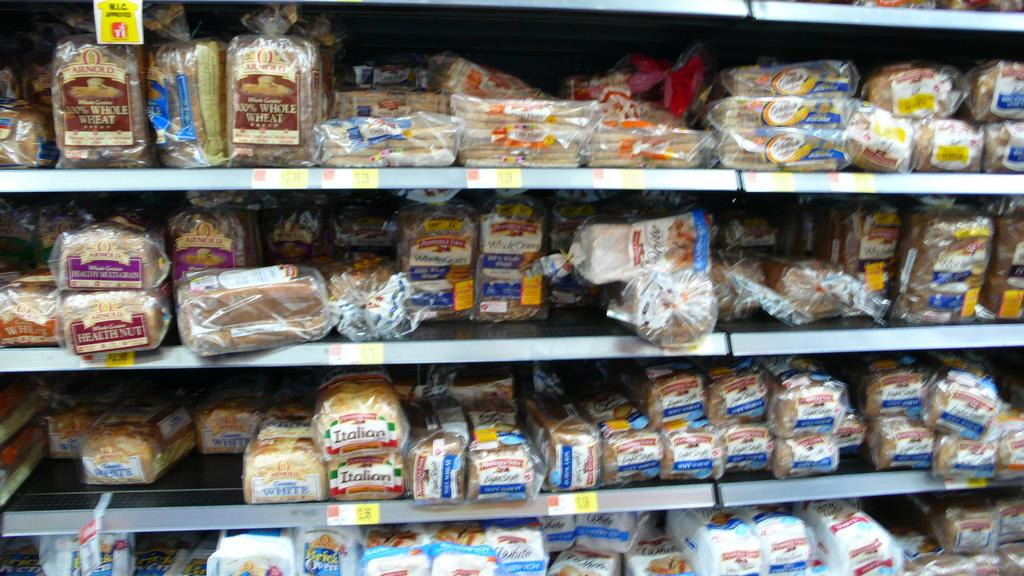What can be found on the shelves in the image? There are food items on the shelves. How can you identify the different food items? Each food item has a label. What information is provided on the shelves? There are price tags on the shelves. Where can you find a library in the image? There is no library present in the image. How many tickets are visible in the image? There are no tickets visible in the image. 